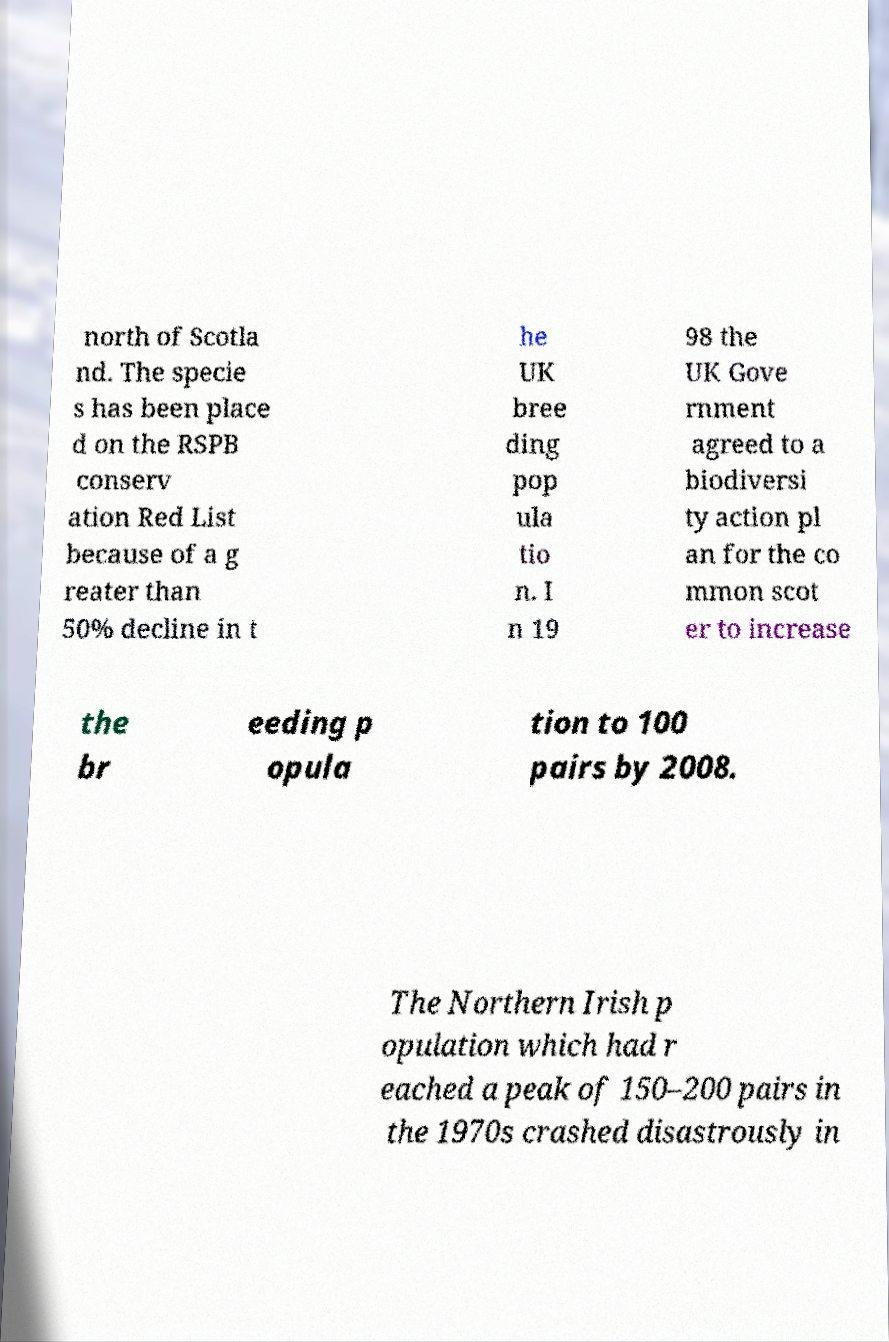For documentation purposes, I need the text within this image transcribed. Could you provide that? north of Scotla nd. The specie s has been place d on the RSPB conserv ation Red List because of a g reater than 50% decline in t he UK bree ding pop ula tio n. I n 19 98 the UK Gove rnment agreed to a biodiversi ty action pl an for the co mmon scot er to increase the br eeding p opula tion to 100 pairs by 2008. The Northern Irish p opulation which had r eached a peak of 150–200 pairs in the 1970s crashed disastrously in 